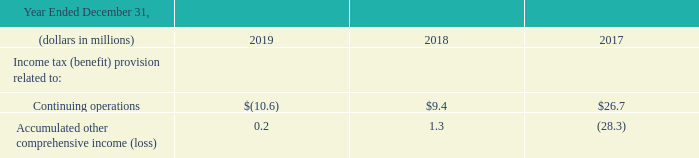The income tax (benefit) provision was charged to continuing operations or accumulated other comprehensive income (loss) as follows:
Prior year balances related to deferred tax assets and liabilities have been recast to net the federal effect of state taxes with the specific deferred tax asset or liability to which it relates
What is the income tax (benefit) provision related to continuing operations in 2017?
Answer scale should be: million. $26.7. What is the income tax (benefit) provision related to continuing operations in 2018?
Answer scale should be: million. $9.4. What is the income tax (benefit) provision related to accumulated other comprehensive income in 2018?
Answer scale should be: million. 1.3. What is the income tax (benefit) provision related to continuing operations in 2017 and 2018?
Answer scale should be: million. $26.7+$9.4
Answer: 36.1. What is the percentage change in income tax from accumulated other comprehensive income between 2018 and 2019?
Answer scale should be: percent. (0.2-1.3)/1.3
Answer: -84.62. What is the total income tax provision relate to continuing operations between 2017 to 2019?
Answer scale should be: million. $(10.6) +$9.4 +$26.7
Answer: 25.5. 